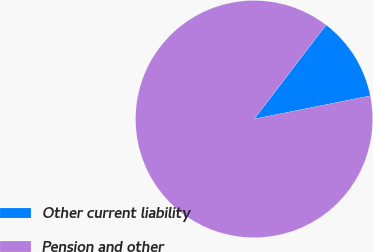Convert chart. <chart><loc_0><loc_0><loc_500><loc_500><pie_chart><fcel>Other current liability<fcel>Pension and other<nl><fcel>11.47%<fcel>88.53%<nl></chart> 